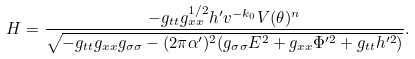<formula> <loc_0><loc_0><loc_500><loc_500>H = \frac { - g _ { t t } g _ { x x } ^ { 1 / 2 } h ^ { \prime } v ^ { - k _ { 0 } } V ( \theta ) ^ { n } } { \sqrt { - g _ { t t } g _ { x x } g _ { \sigma \sigma } - ( 2 \pi \alpha ^ { \prime } ) ^ { 2 } ( g _ { \sigma \sigma } E ^ { 2 } + g _ { x x } \Phi ^ { \prime 2 } + g _ { t t } h ^ { \prime 2 } ) } } .</formula> 